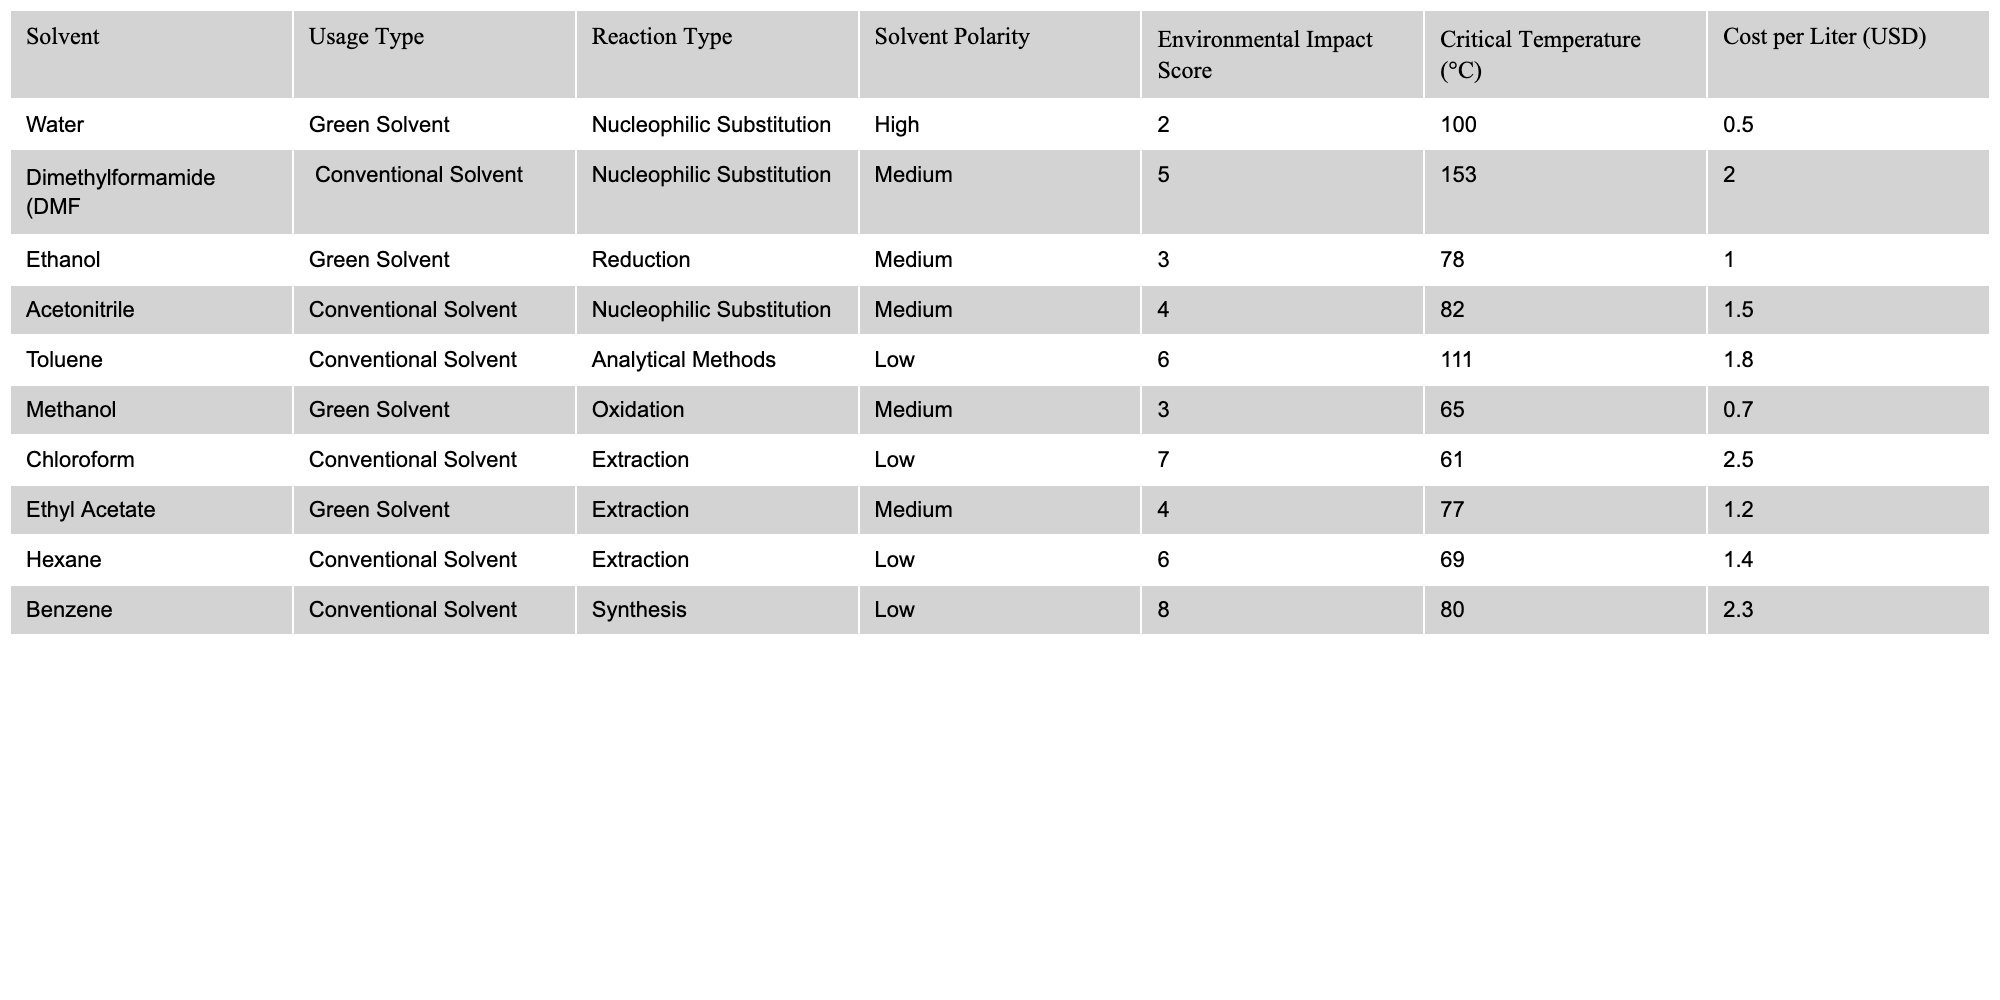What is the cost per liter of Water? The table shows that the cost per liter of Water is listed under the "Cost per Liter" column. The corresponding value for Water is 0.50 USD.
Answer: 0.50 USD Which solvent has the highest environmental impact score? By comparing the values in the "Environmental Impact Score" column, the maximum score is 8, which corresponds to Benzene.
Answer: Benzene How many solvents are classified as green solvents? The table lists solvents under the "Usage Type" column as either Green Solvent or Conventional Solvent. There are three entries under Green Solvent: Water, Ethanol, and Methanol.
Answer: 3 What is the average critical temperature of all solvents listed? To find the average critical temperature, add all the critical temperatures: 100 + 153 + 78 + 82 + 111 + 65 + 61 + 77 + 69 + 80 =  796, then divide by the number of solvents, which is 10: 796 / 10 = 79.6 °C.
Answer: 79.6 °C Is Ethanol a conventional solvent? Ethanol is classified as a Green Solvent in the table, not a Conventional Solvent.
Answer: No Which solvent has the lowest polarity, and what is its usage type? The poles of polarity are categorized as High, Medium, and Low. The solvent with Low polarity is Toluene, and its usage type is listed as Conventional Solvent.
Answer: Toluene, Conventional Solvent What is the total cost of the solvents that are classified as green solvents? The costs for the green solvents are summed as follows: Water (0.50) + Ethanol (1.00) + Methanol (0.70) = 2.20 USD.
Answer: 2.20 USD How do the environmental impact scores of DMF and Acetonitrile compare? Checking the scores under "Environmental Impact Score", DMF has a score of 5, while Acetonitrile has a score of 4, indicating that DMF has a higher score than Acetonitrile.
Answer: DMF is higher What solvent types are used for nucleophilic substitution reactions, and which has the lowest cost? The table shows that both Water and DMF are used for nucleophilic substitution; their respective costs are 0.50 USD and 2.00 USD. The lowest cost is 0.50 USD for Water.
Answer: Water If we exclude conventional solvents, what would be the environmental impact score of the remaining solvents? The environmental impact scores of the remaining green solvents (Water, Ethanol, Methanol) are 2, 3, and 3, respectively. The total score is 2 + 3 + 3 = 8.
Answer: 8 Which solvent has the highest cost, and what reaction type is it associated with? Checking the "Cost per Liter" column, Chloroform has the highest cost at 2.50 USD, and it is associated with the Extraction reaction type.
Answer: Chloroform, Extraction 